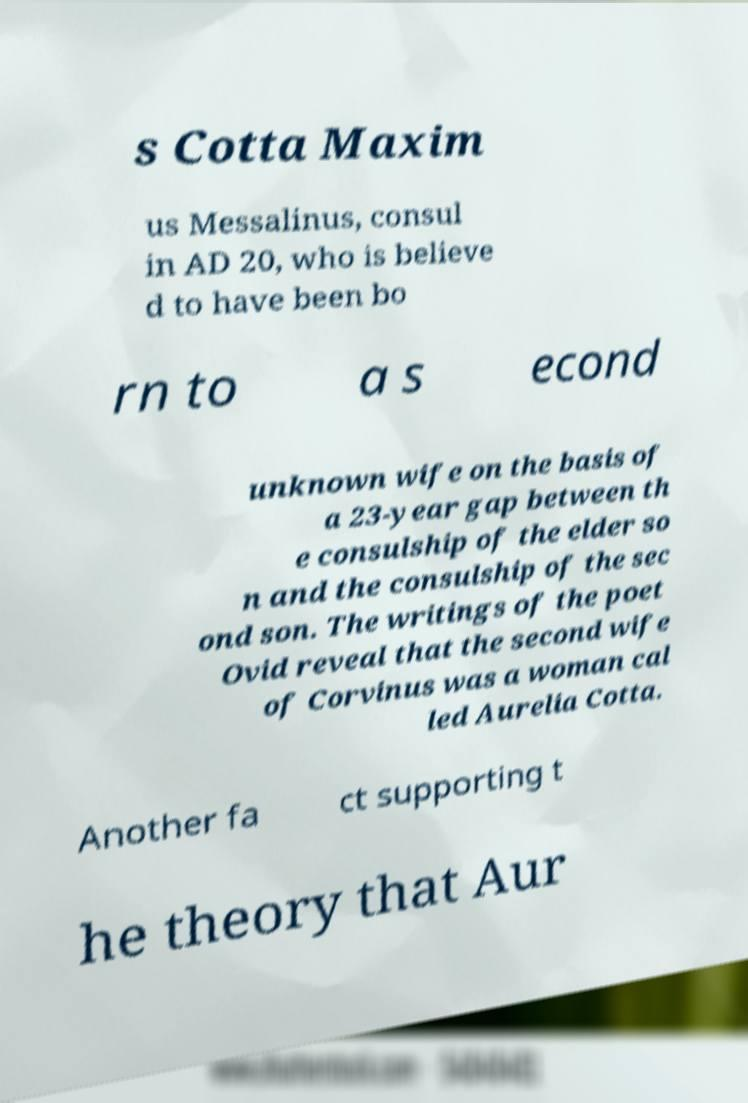I need the written content from this picture converted into text. Can you do that? s Cotta Maxim us Messalinus, consul in AD 20, who is believe d to have been bo rn to a s econd unknown wife on the basis of a 23-year gap between th e consulship of the elder so n and the consulship of the sec ond son. The writings of the poet Ovid reveal that the second wife of Corvinus was a woman cal led Aurelia Cotta. Another fa ct supporting t he theory that Aur 